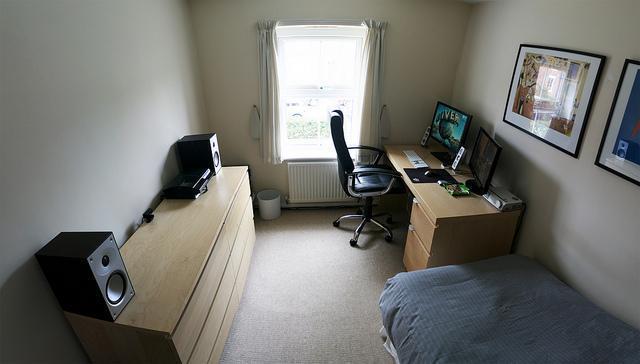How many pieces of framed artwork are on the wall?
Give a very brief answer. 2. 